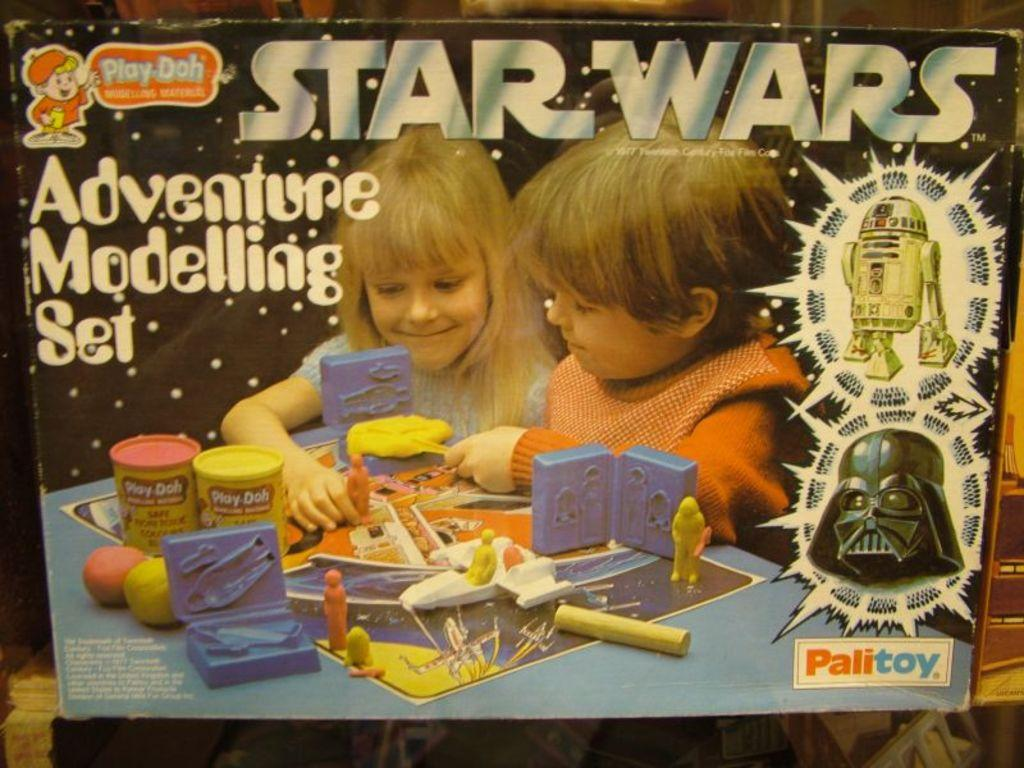What object is present in the image? There is a box in the image. What are the two persons in the image doing? They are playing with toys on the box. What type of toothpaste is being used by the persons in the image? There is no toothpaste present in the image; the two persons are playing with toys on a box. 